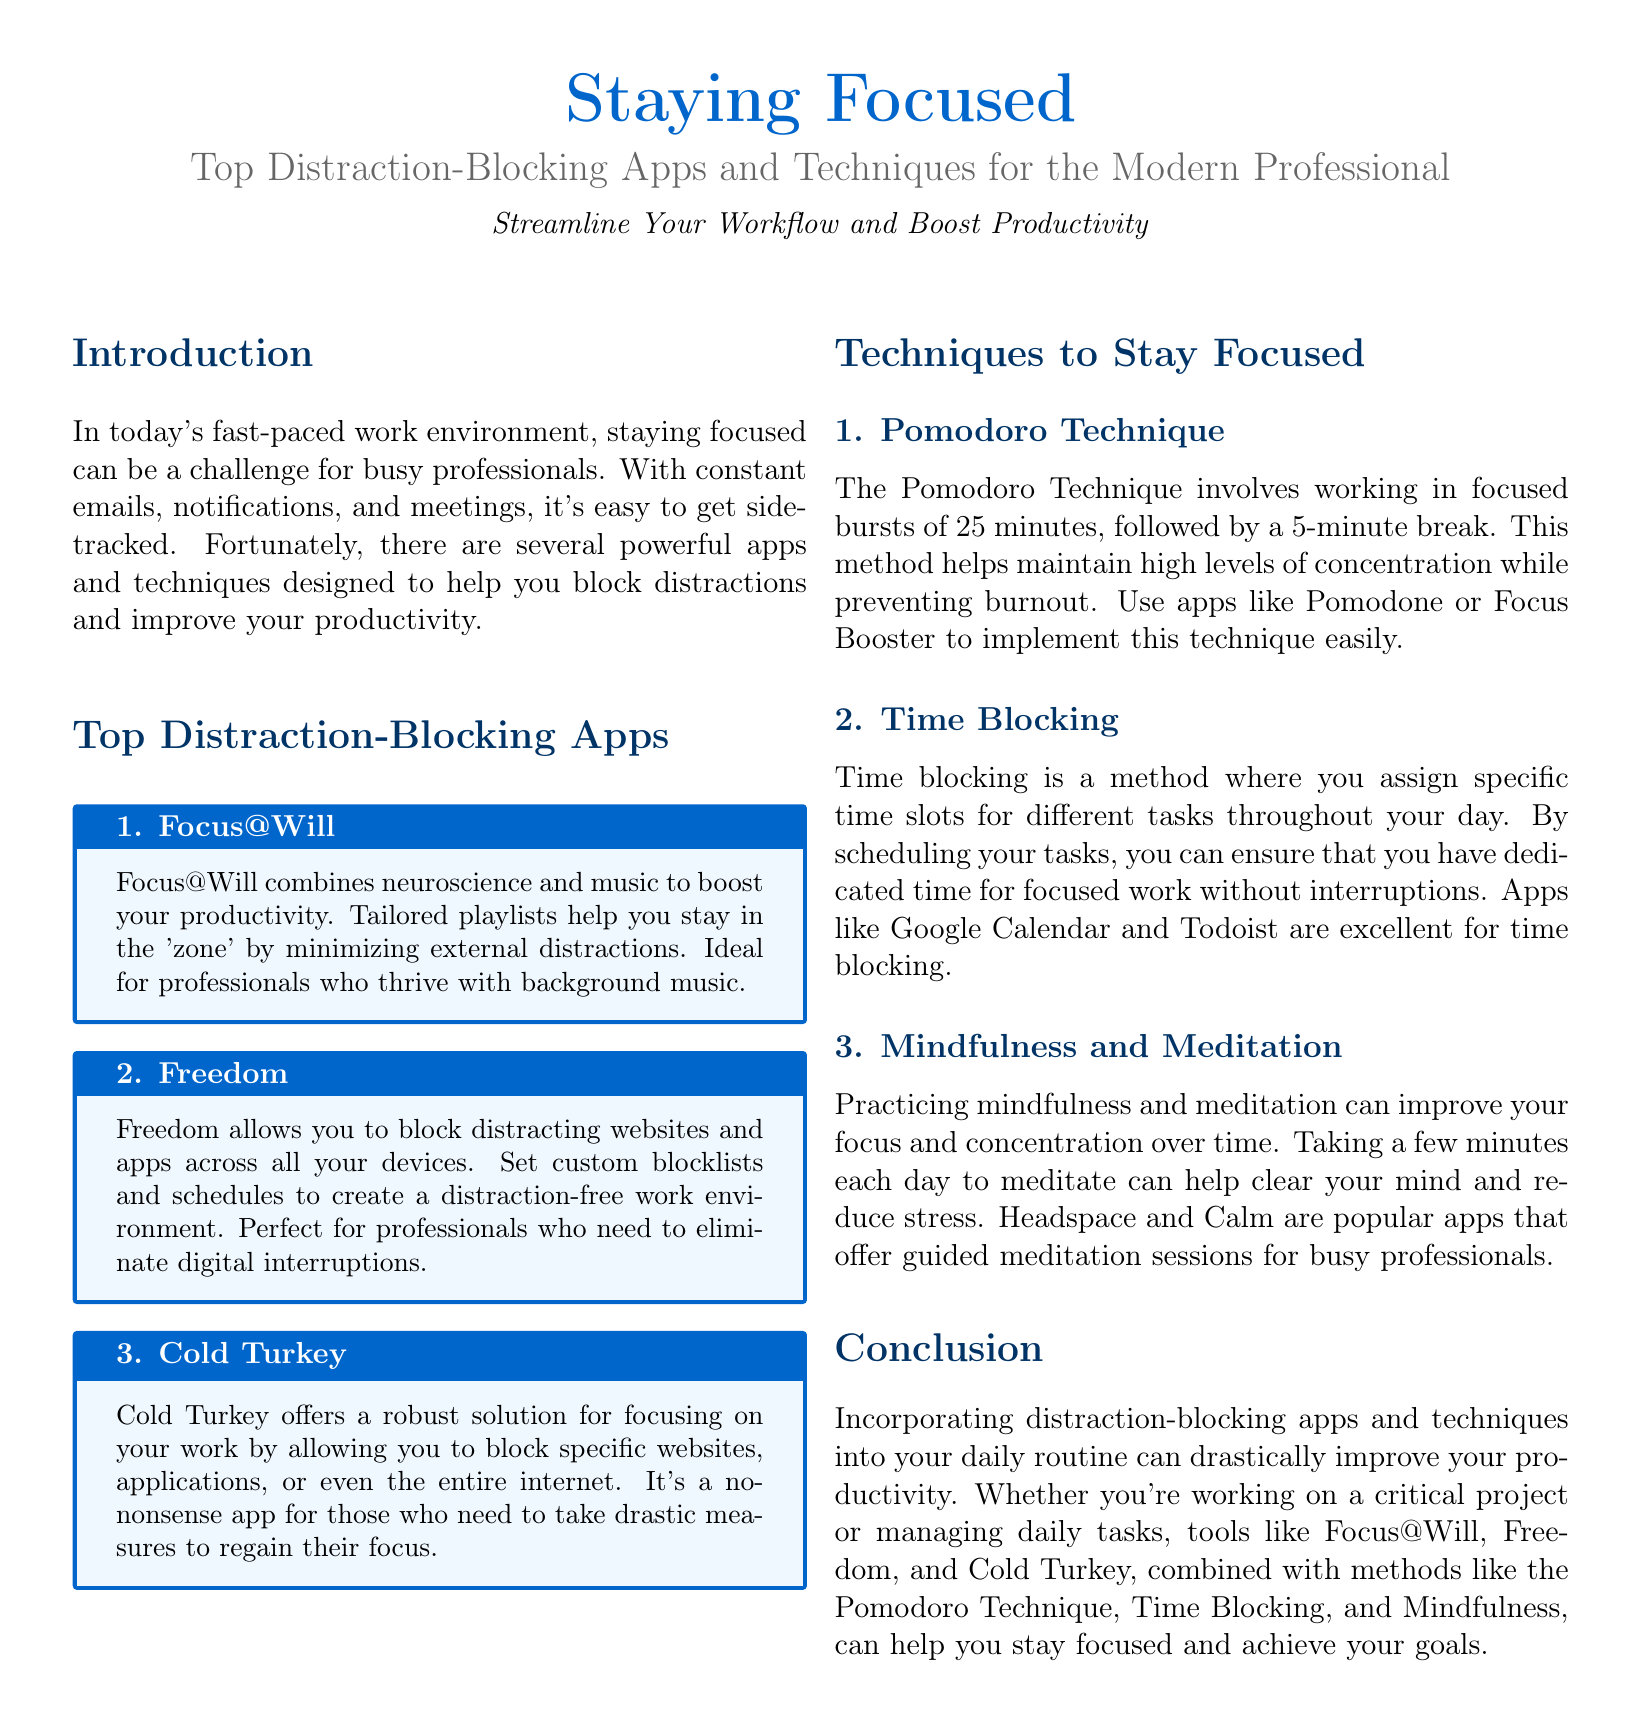What is the title of the document? The title is prominently displayed at the top of the document, indicating the main topic covered.
Answer: Staying Focused What is the subtitle of the document? The subtitle provides additional context and focus on what the document is about.
Answer: Top Distraction-Blocking Apps and Techniques for the Modern Professional How many distraction-blocking apps are listed in the document? The document lists three distraction-blocking apps.
Answer: 3 What technique involves working in focused bursts followed by breaks? This technique is specifically mentioned in the section on techniques, providing a method to enhance focus.
Answer: Pomodoro Technique Which app combines neuroscience and music? The document specifies an app that uniquely integrates music with productivity techniques.
Answer: Focus@Will What are two apps mentioned for guided meditation? The conclusion states that these two apps are popular amongst busy professionals looking to improve focus through meditation.
Answer: Headspace and Calm Which method involves assigning specific time slots for tasks? This method is described as a way to enhance productivity by minimizing interruptions and ensuring focus.
Answer: Time Blocking What is the purpose of the Freedom app? The purpose of the app is clearly explained in the app descriptions, indicating its role in enhancing focus for users.
Answer: Block distracting websites and apps What does the section on techniques include besides the Pomodoro Technique? The section lists various techniques, highlighting ways to maintain concentration and manage time effectively.
Answer: Time Blocking and Mindfulness 